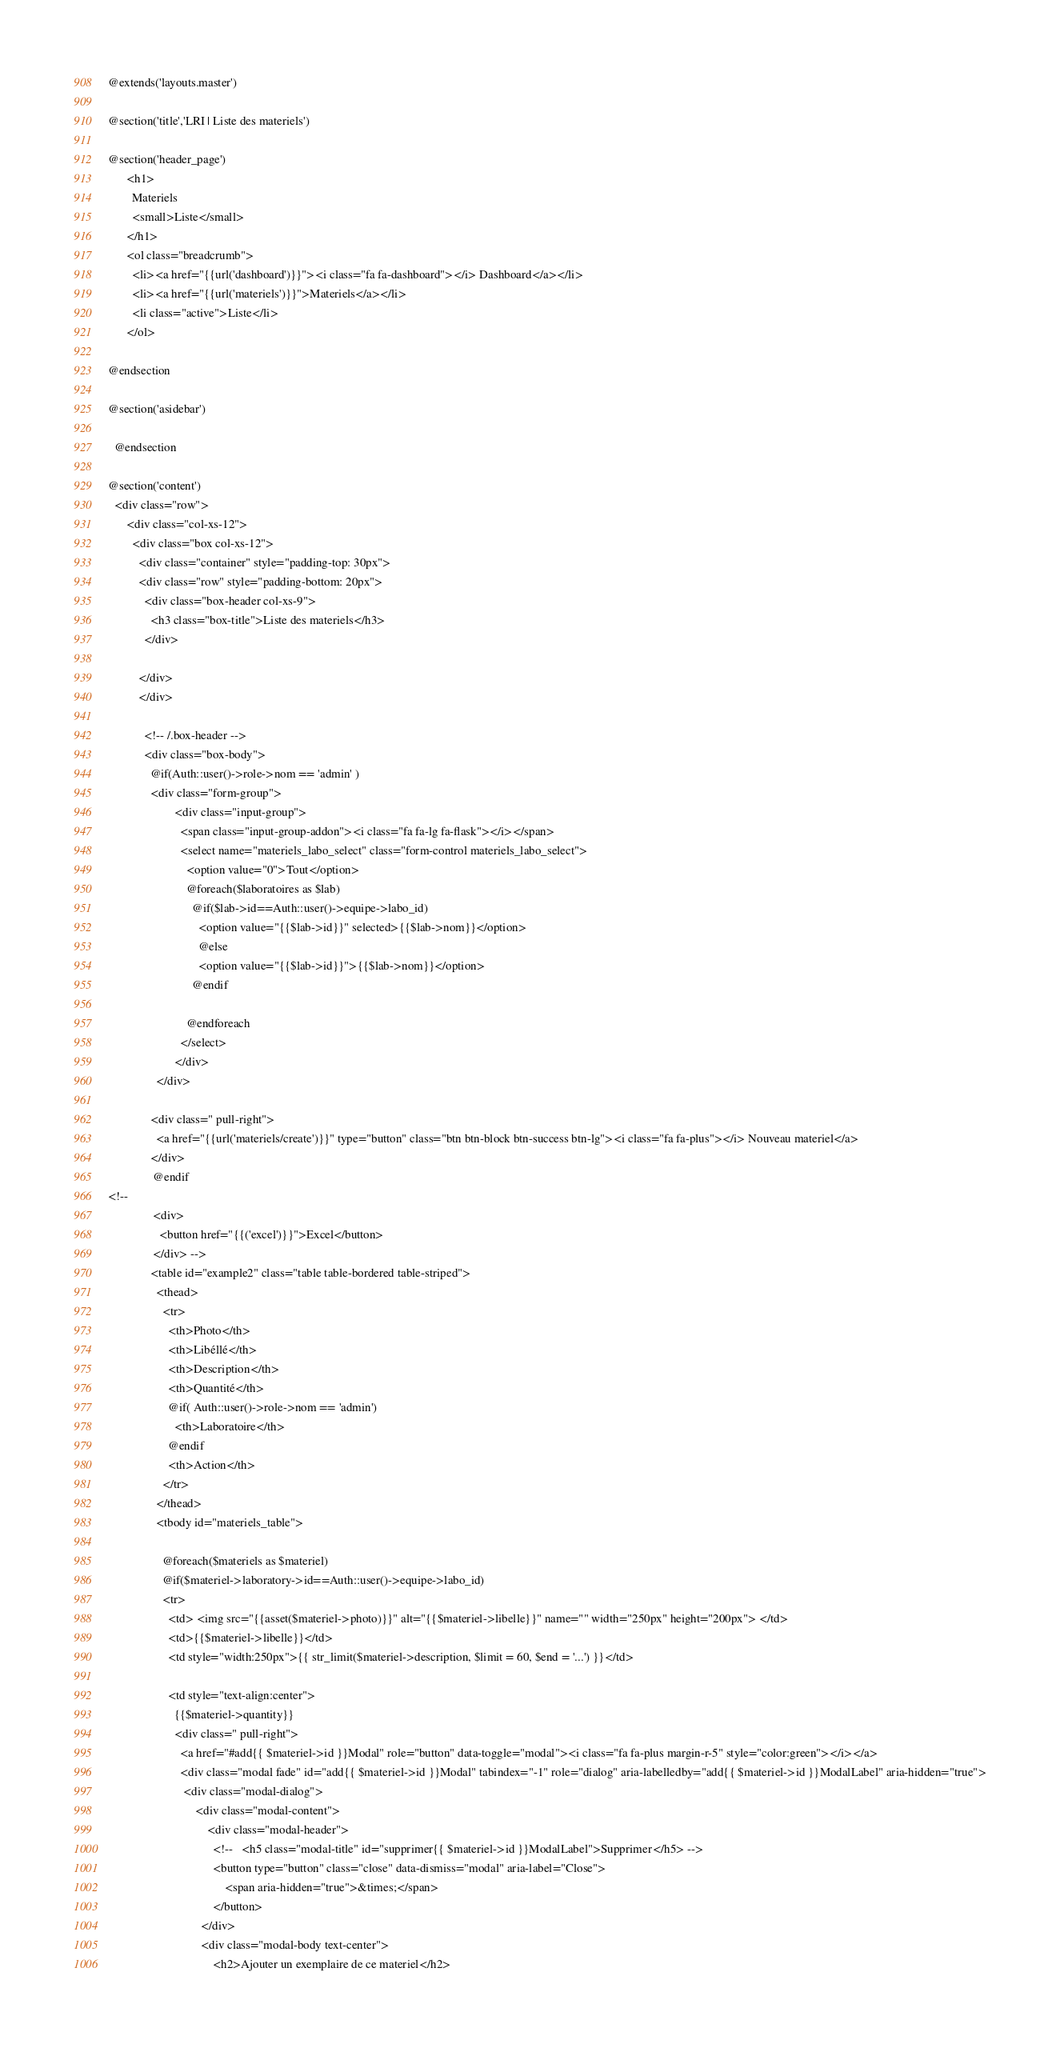<code> <loc_0><loc_0><loc_500><loc_500><_PHP_>
@extends('layouts.master')

@section('title','LRI | Liste des materiels')

@section('header_page')
      <h1>
        Materiels
        <small>Liste</small>
      </h1>
      <ol class="breadcrumb">
        <li><a href="{{url('dashboard')}}"><i class="fa fa-dashboard"></i> Dashboard</a></li>
        <li><a href="{{url('materiels')}}">Materiels</a></li>
        <li class="active">Liste</li>
      </ol>

@endsection

@section('asidebar')

  @endsection

@section('content')
  <div class="row">
      <div class="col-xs-12">
        <div class="box col-xs-12">
          <div class="container" style="padding-top: 30px">
          <div class="row" style="padding-bottom: 20px">
            <div class="box-header col-xs-9">
              <h3 class="box-title">Liste des materiels</h3>
            </div>

          </div>
          </div>

            <!-- /.box-header -->
            <div class="box-body">
              @if(Auth::user()->role->nom == 'admin' )
              <div class="form-group">
                      <div class="input-group">
                        <span class="input-group-addon"><i class="fa fa-lg fa-flask"></i></span>
                        <select name="materiels_labo_select" class="form-control materiels_labo_select">
                          <option value="0">Tout</option>
                          @foreach($laboratoires as $lab)
                            @if($lab->id==Auth::user()->equipe->labo_id)
                              <option value="{{$lab->id}}" selected>{{$lab->nom}}</option>
                              @else
                              <option value="{{$lab->id}}">{{$lab->nom}}</option>
                            @endif

                          @endforeach
                        </select>
                      </div>
                </div>

              <div class=" pull-right">
                <a href="{{url('materiels/create')}}" type="button" class="btn btn-block btn-success btn-lg"><i class="fa fa-plus"></i> Nouveau materiel</a>
              </div>
               @endif
<!--
               <div>
                 <button href="{{('excel')}}">Excel</button>
               </div> -->
              <table id="example2" class="table table-bordered table-striped">
                <thead>
                  <tr>
                    <th>Photo</th>
                    <th>Libéllé</th>
                    <th>Description</th>
                    <th>Quantité</th>
                    @if( Auth::user()->role->nom == 'admin')
                      <th>Laboratoire</th>
                    @endif
                    <th>Action</th>
                  </tr>
                </thead>
                <tbody id="materiels_table">

                  @foreach($materiels as $materiel)
                  @if($materiel->laboratory->id==Auth::user()->equipe->labo_id)
                  <tr>
                    <td> <img src="{{asset($materiel->photo)}}" alt="{{$materiel->libelle}}" name="" width="250px" height="200px"> </td>
                    <td>{{$materiel->libelle}}</td>
                    <td style="width:250px">{{ str_limit($materiel->description, $limit = 60, $end = '...') }}</td>

                    <td style="text-align:center">
                      {{$materiel->quantity}}
                      <div class=" pull-right">
                        <a href="#add{{ $materiel->id }}Modal" role="button" data-toggle="modal"><i class="fa fa-plus margin-r-5" style="color:green"></i></a>
                        <div class="modal fade" id="add{{ $materiel->id }}Modal" tabindex="-1" role="dialog" aria-labelledby="add{{ $materiel->id }}ModalLabel" aria-hidden="true">
                         <div class="modal-dialog">
                             <div class="modal-content">
                                 <div class="modal-header">
                                   <!--   <h5 class="modal-title" id="supprimer{{ $materiel->id }}ModalLabel">Supprimer</h5> -->
                                   <button type="button" class="close" data-dismiss="modal" aria-label="Close">
                                       <span aria-hidden="true">&times;</span>
                                   </button>
                               </div>
                               <div class="modal-body text-center">
                                   <h2>Ajouter un exemplaire de ce materiel</h2></code> 